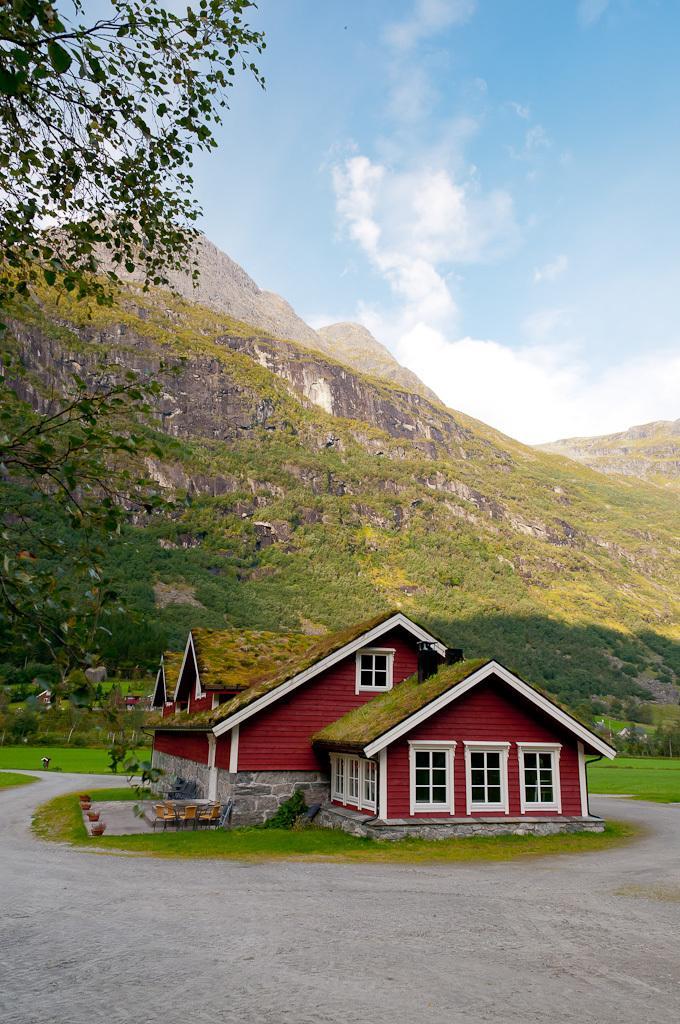Describe this image in one or two sentences. In this image we can see a house, also there are some house plants, flower pots, chairs, window, behind the house we see mountains, also we can see some trees and the sky. 